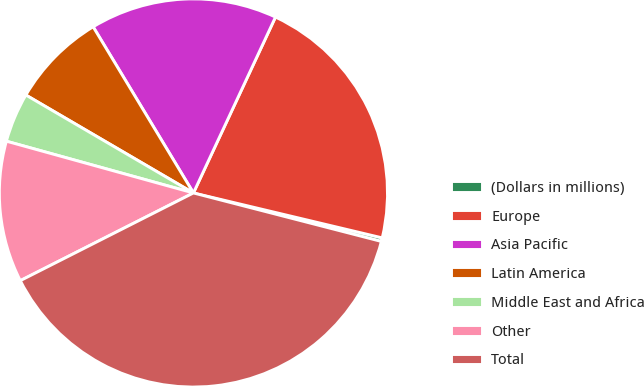Convert chart. <chart><loc_0><loc_0><loc_500><loc_500><pie_chart><fcel>(Dollars in millions)<fcel>Europe<fcel>Asia Pacific<fcel>Latin America<fcel>Middle East and Africa<fcel>Other<fcel>Total<nl><fcel>0.3%<fcel>21.77%<fcel>15.59%<fcel>7.94%<fcel>4.12%<fcel>11.76%<fcel>38.52%<nl></chart> 